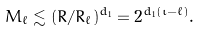<formula> <loc_0><loc_0><loc_500><loc_500>M _ { \ell } \lesssim ( R / R _ { \ell } ) ^ { d _ { 1 } } = 2 ^ { d _ { 1 } ( \iota - \ell ) } .</formula> 